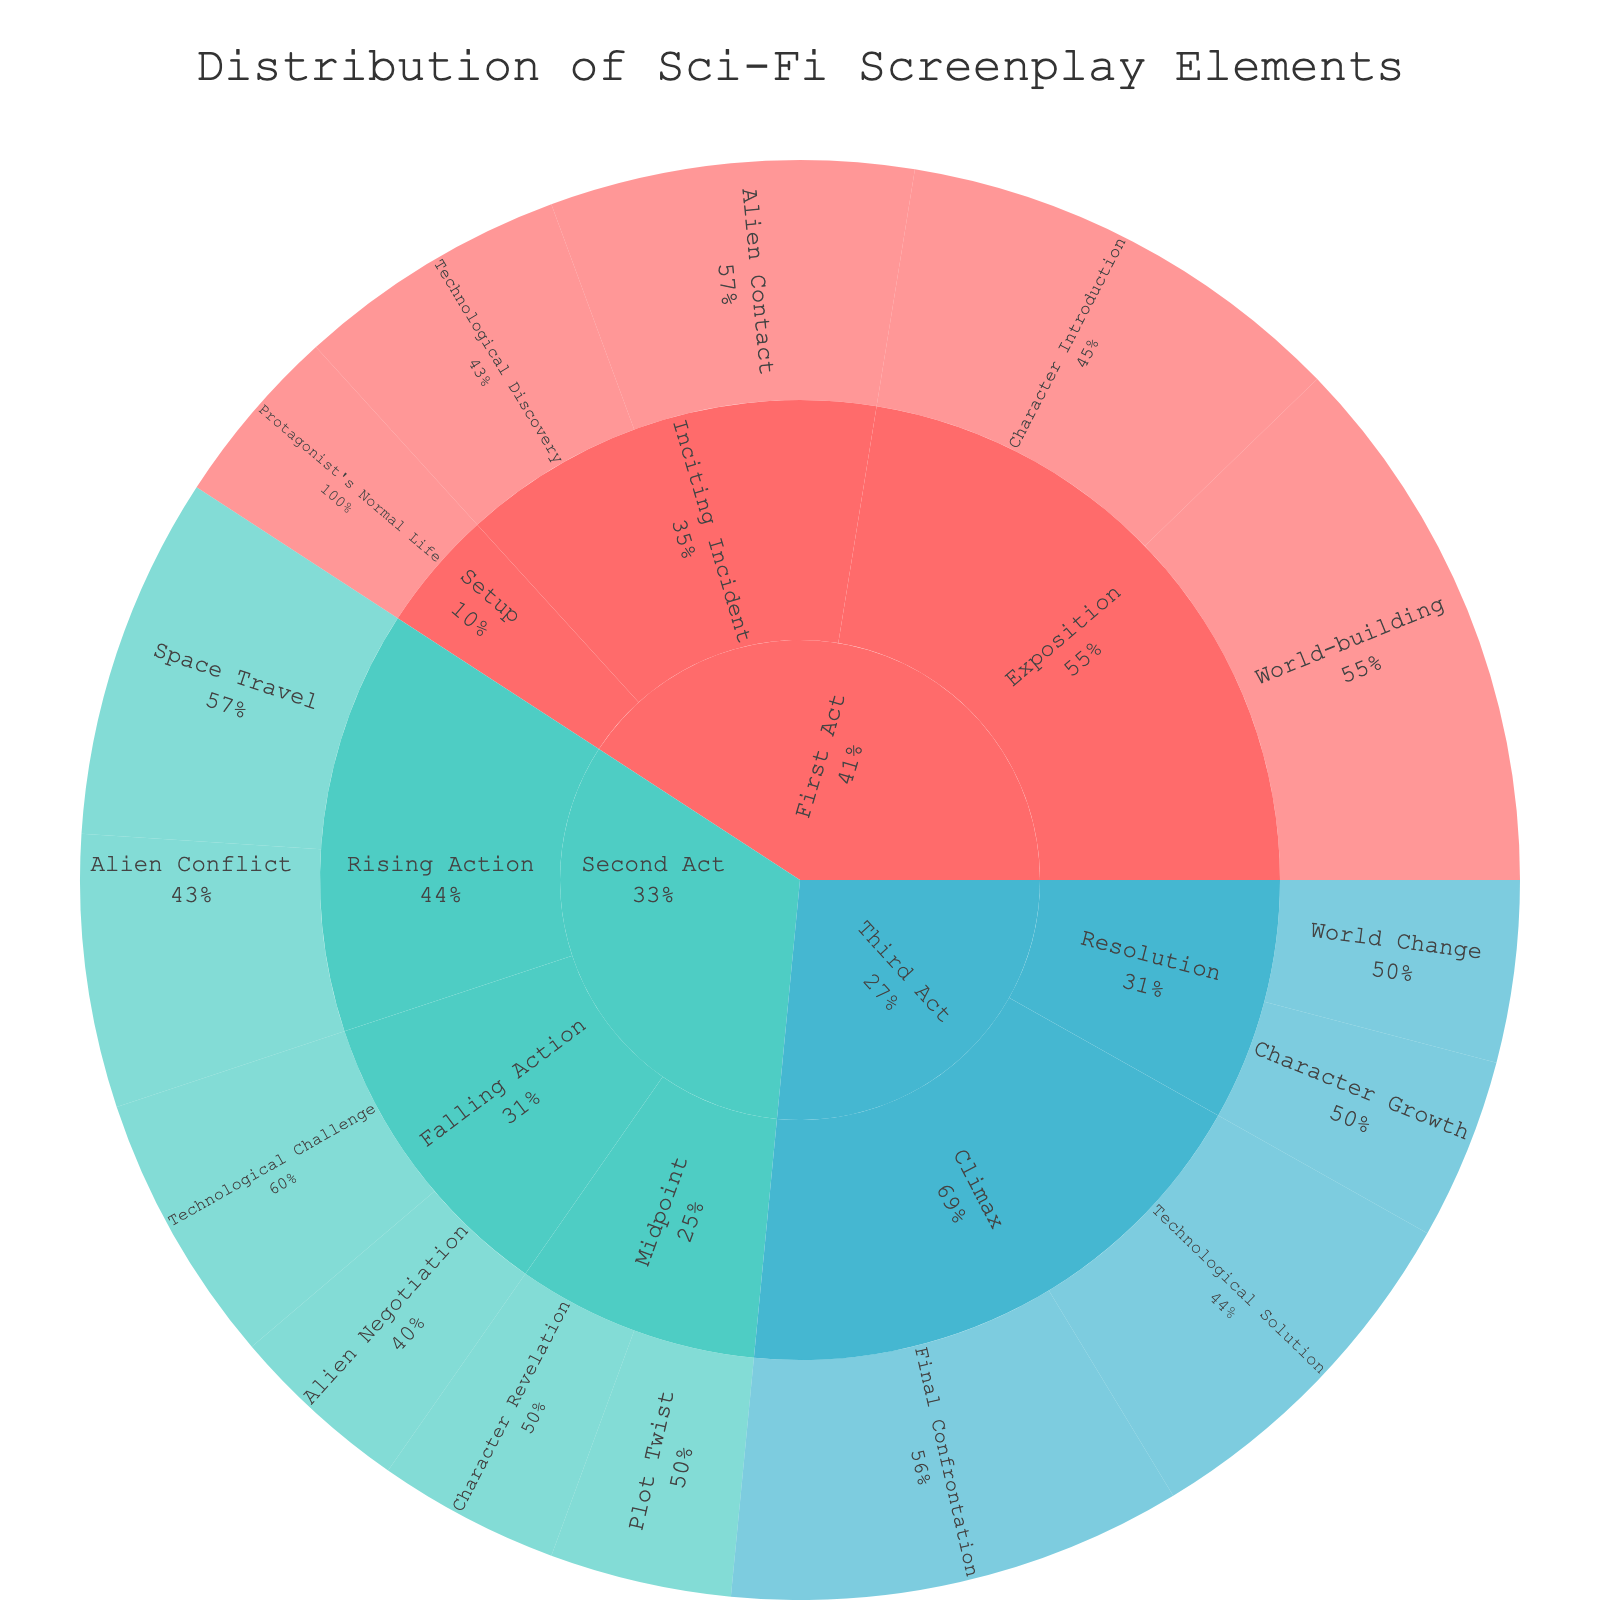What is the title of the sunburst plot? The title is usually displayed at the top of the plot. In this case, the title is "Distribution of Sci-Fi Screenplay Elements".
Answer: Distribution of Sci-Fi Screenplay Elements Which act contains the element 'Alien Contact'? By observing the path in the sunburst plot, you can find that 'Alien Contact' is located in the 'First Act' under the 'Inciting Incident' scene type.
Answer: First Act What percentage of the First Act is dedicated to 'Character Introduction'? Under the First Act, you can see 'Character Introduction' in the Exposition scene type with a specific percentage value.
Answer: 25% How does the percentage of 'Space Travel' in the Second Act compare to 'Protagonist's Normal Life' in the First Act? 'Space Travel' is in the Second Act - Rising Action (20%), and 'Protagonist's Normal Life' is in the First Act - Setup (10%). Comparing these values, you can see that 'Space Travel' is greater.
Answer: Space Travel (20%) is greater than Protagonist's Normal Life (10%) What is the total percentage representation of 'Rising Action' in the Second Act? 'Rising Action' in the Second Act includes 'Space Travel' (20%) and 'Alien Conflict' (15%). Adding these values gives 35%.
Answer: 35% Which element has the highest percentage in the Third Act? In the Third Act, you have 'Final Confrontation' (25%), 'Technological Solution' (20%), 'Character Growth' (10%), and 'World Change' (10%). The highest value here is for 'Final Confrontation'.
Answer: Final Confrontation What role does 'Character Growth' play in the overall structure in terms of percentage? 'Character Growth' appears in the Third Act under 'Resolution' with a percentage of 10%. As part of the overall structure, it plays a minor role.
Answer: 10% How does the combined percentage of 'World Change' and 'Character Growth' in the Third Act compare to 'Plot Twist' in the Second Act? Both 'World Change' and 'Character Growth' in the Third Act have individual percentages of 10%. When combined, they sum to 20%. In the Second Act, 'Plot Twist' under 'Midpoint' is 10%. Therefore, the combined percentage (20%) is greater than 'Plot Twist' (10%).
Answer: Combined percentage (20%) is greater than Plot Twist (10%) How does 'Technological Discovery' in the First Act compare to 'Technological Challenge' in the Second Act? 'Technological Discovery' is in the First Act – Inciting Incident (15%) and 'Technological Challenge' is in the Second Act – Falling Action (15%). Both percentages are equal.
Answer: Equal (both 15%) What scene type has the most elements in the Third Act? In the Third Act, the scene types are 'Climax' and 'Resolution'. 'Climax' contains 'Final Confrontation' and 'Technological Solution', while 'Resolution' contains 'Character Growth' and 'World Change'. Each scene type has 2 elements.
Answer: Both Climax and Resolution have 2 elements 